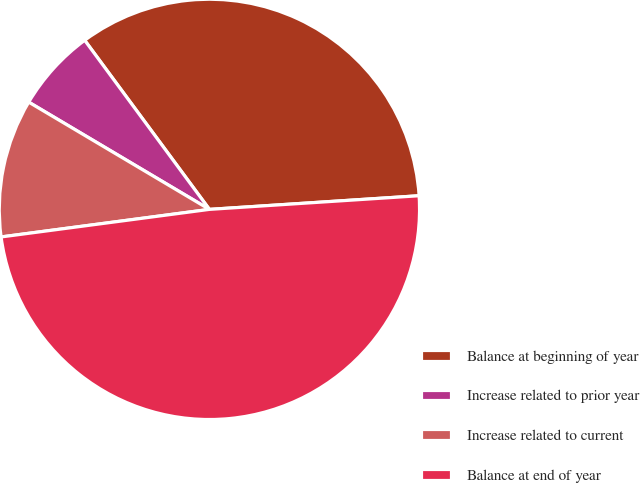<chart> <loc_0><loc_0><loc_500><loc_500><pie_chart><fcel>Balance at beginning of year<fcel>Increase related to prior year<fcel>Increase related to current<fcel>Balance at end of year<nl><fcel>34.08%<fcel>6.36%<fcel>10.62%<fcel>48.94%<nl></chart> 